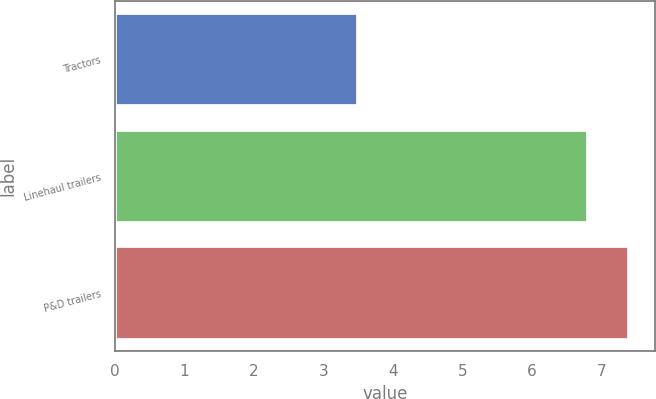Convert chart. <chart><loc_0><loc_0><loc_500><loc_500><bar_chart><fcel>Tractors<fcel>Linehaul trailers<fcel>P&D trailers<nl><fcel>3.5<fcel>6.8<fcel>7.4<nl></chart> 